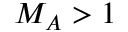<formula> <loc_0><loc_0><loc_500><loc_500>M _ { A } > 1</formula> 